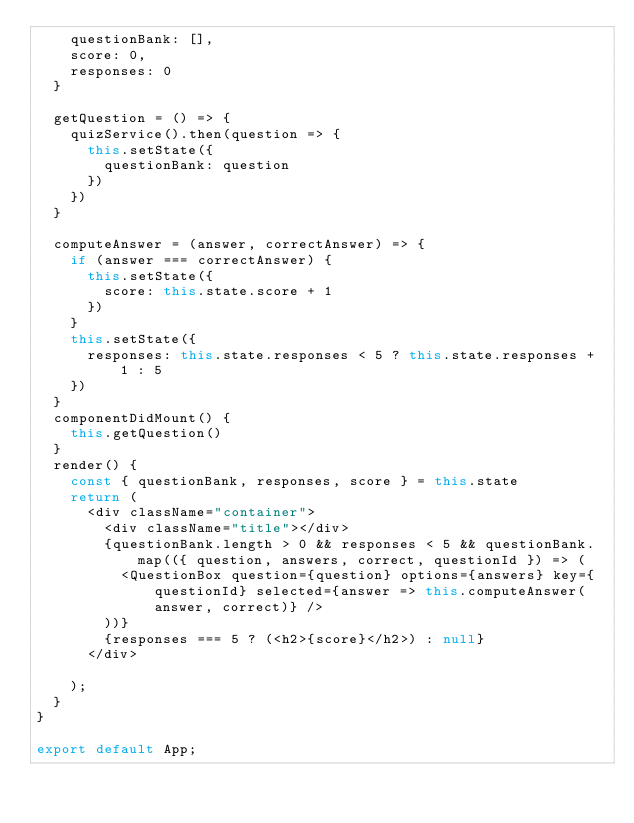Convert code to text. <code><loc_0><loc_0><loc_500><loc_500><_JavaScript_>    questionBank: [],
    score: 0,
    responses: 0
  }

  getQuestion = () => {
    quizService().then(question => {
      this.setState({
        questionBank: question
      })
    })
  }

  computeAnswer = (answer, correctAnswer) => {
    if (answer === correctAnswer) {
      this.setState({
        score: this.state.score + 1
      })
    }
    this.setState({
      responses: this.state.responses < 5 ? this.state.responses + 1 : 5
    })
  }
  componentDidMount() {
    this.getQuestion()
  }
  render() {
    const { questionBank, responses, score } = this.state
    return (
      <div className="container">
        <div className="title"></div>
        {questionBank.length > 0 && responses < 5 && questionBank.map(({ question, answers, correct, questionId }) => (
          <QuestionBox question={question} options={answers} key={questionId} selected={answer => this.computeAnswer(answer, correct)} />
        ))}
        {responses === 5 ? (<h2>{score}</h2>) : null}
      </div>

    );
  }
}

export default App;
</code> 